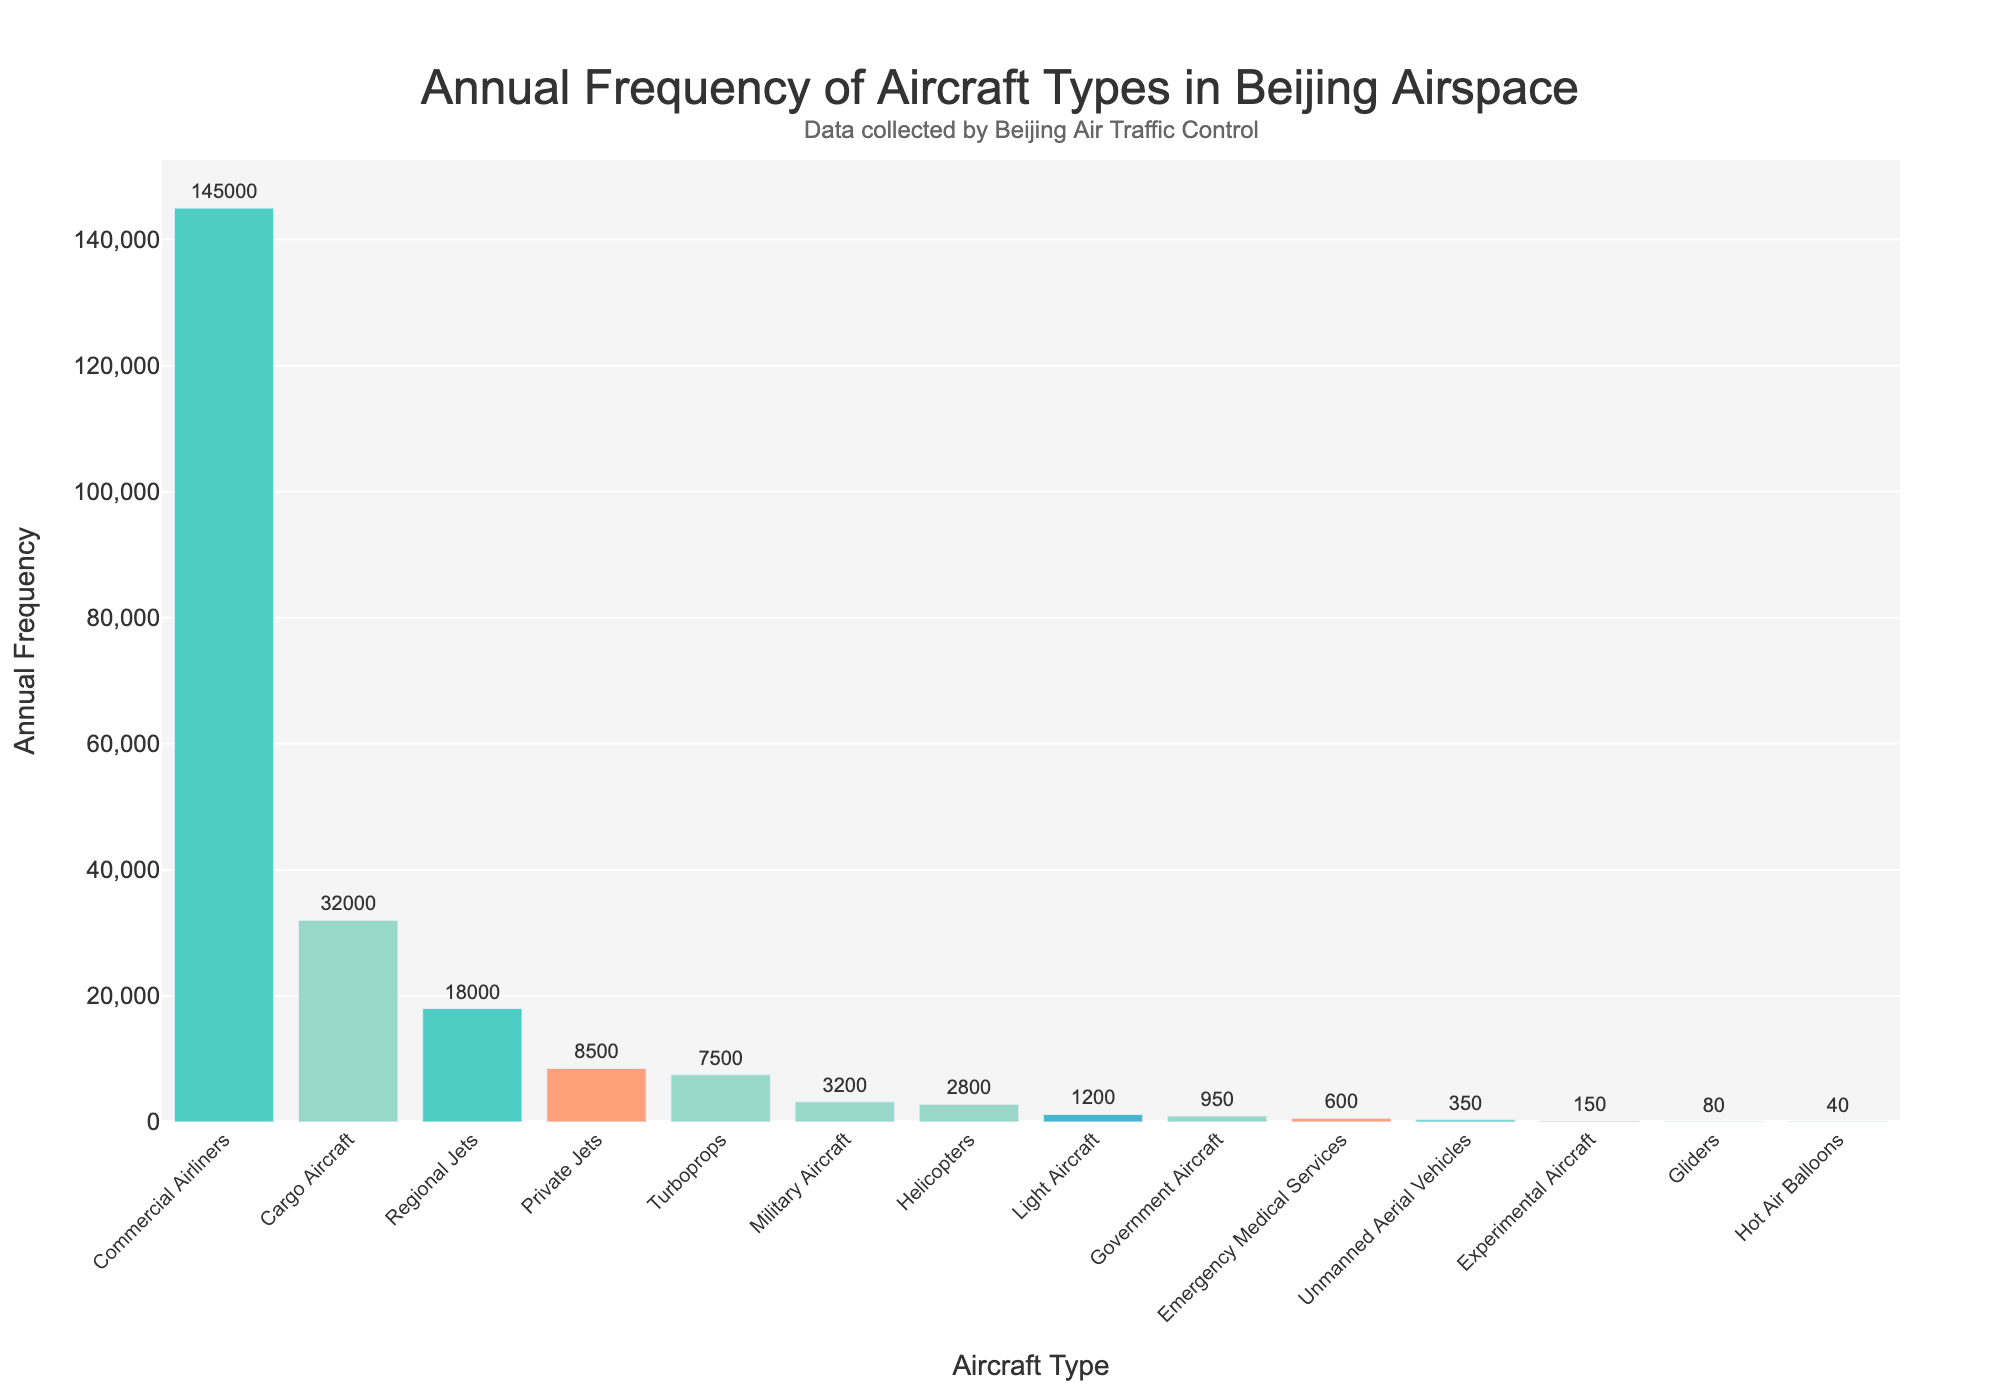What is the most frequent type of aircraft encountered in Beijing airspace annually? The tallest bar in the figure corresponds to "Commercial Airliners" with an annual frequency of 145,000, indicating it is the most frequent type.
Answer: Commercial Airliners What is the difference in annual frequency between Cargo Aircraft and Regional Jets? The annual frequency of Cargo Aircraft is 32,000, and that of Regional Jets is 18,000. The difference is 32,000 - 18,000 = 14,000.
Answer: 14,000 How many more Private Jets are encountered than Helicopters annually? The annual frequency of Private Jets is 8,500, and that of Helicopters is 2,800. Thus, 8,500 - 2,800 = 5,700 more Private Jets are encountered annually.
Answer: 5,700 Which type of aircraft has the lowest annual frequency and what is it? The shortest bar in the figure corresponds to "Hot Air Balloons" with an annual frequency of 40, making it the type with the lowest frequency.
Answer: Hot Air Balloons, 40 What is the total annual frequency of aircraft types excluding "Commercial Airliners"? Sum the frequencies of all types except "Commercial Airliners" (32,000 + 8,500 + 3,200 + 2,800 + 7,500 + 18,000 + 1,200 + 950 + 600 + 150 + 80 + 40 + 350) = 75,370.
Answer: 75,370 How does the annual frequency of Turboprops compare to Helicopters? The annual frequency of Turboprops is 7,500, which is higher than the 2,800 annual frequency of Helicopters.
Answer: Turboprops > Helicopters What is the combined annual frequency of Emergency Medical Services and Experimental Aircraft? Summing the annual frequencies of Emergency Medical Services (600) and Experimental Aircraft (150) gives 600 + 150 = 750.
Answer: 750 Which has a higher frequency: Government Aircraft or Unmanned Aerial Vehicles? The annual frequency of Government Aircraft is 950, while that of Unmanned Aerial Vehicles is 350. Hence, Government Aircraft has a higher frequency.
Answer: Government Aircraft What is the total annual frequency of aircraft types with an annual frequency below 1000? Sum the frequencies of Light Aircraft (1,200 > 1000, excluded), Government Aircraft (950), Emergency Medical Services (600), Experimental Aircraft (150), Gliders (80), Hot Air Balloons (40), and Unmanned Aerial Vehicles (350): 950 + 600 + 150 + 80 + 40 + 350 = 2,170.
Answer: 2,170 How many times more frequent are Commercial Airliners compared to Cargo Aircraft? The frequency of Commercial Airliners is 145,000, and that of Cargo Aircraft is 32,000. Thus, 145,000 / 32,000 ≈ 4.53 times more frequent.
Answer: ~4.53 times 